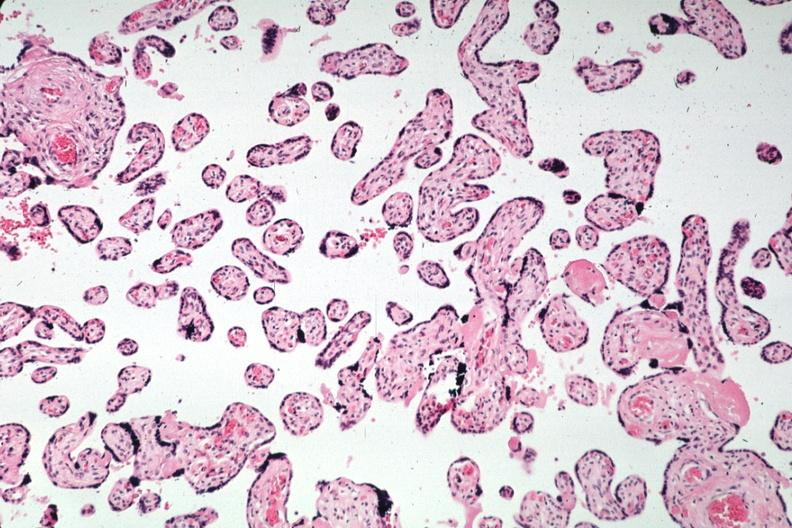what is present?
Answer the question using a single word or phrase. Syncytial knots 